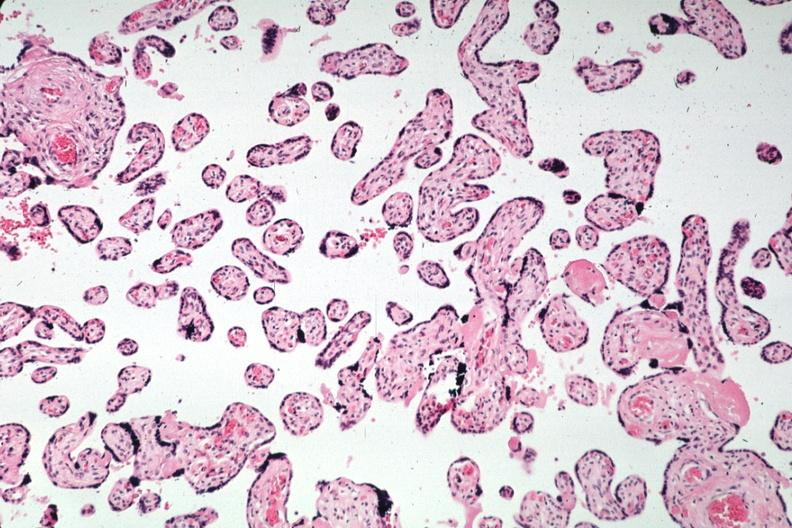what is present?
Answer the question using a single word or phrase. Syncytial knots 